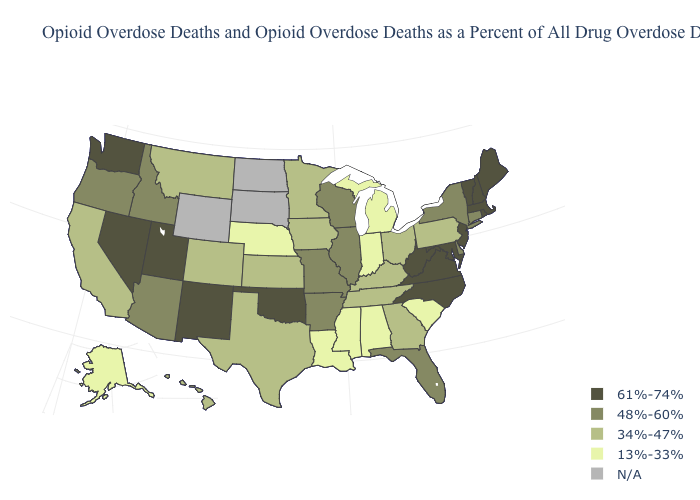Among the states that border Texas , which have the lowest value?
Give a very brief answer. Louisiana. Among the states that border Connecticut , does New York have the lowest value?
Be succinct. Yes. Does Maine have the lowest value in the USA?
Be succinct. No. What is the lowest value in the Northeast?
Write a very short answer. 34%-47%. Which states hav the highest value in the MidWest?
Concise answer only. Illinois, Missouri, Wisconsin. Does Nebraska have the lowest value in the MidWest?
Quick response, please. Yes. Does the map have missing data?
Short answer required. Yes. Does the first symbol in the legend represent the smallest category?
Give a very brief answer. No. Which states have the lowest value in the USA?
Keep it brief. Alabama, Alaska, Indiana, Louisiana, Michigan, Mississippi, Nebraska, South Carolina. What is the highest value in the West ?
Short answer required. 61%-74%. What is the value of Alabama?
Short answer required. 13%-33%. Does the first symbol in the legend represent the smallest category?
Keep it brief. No. 